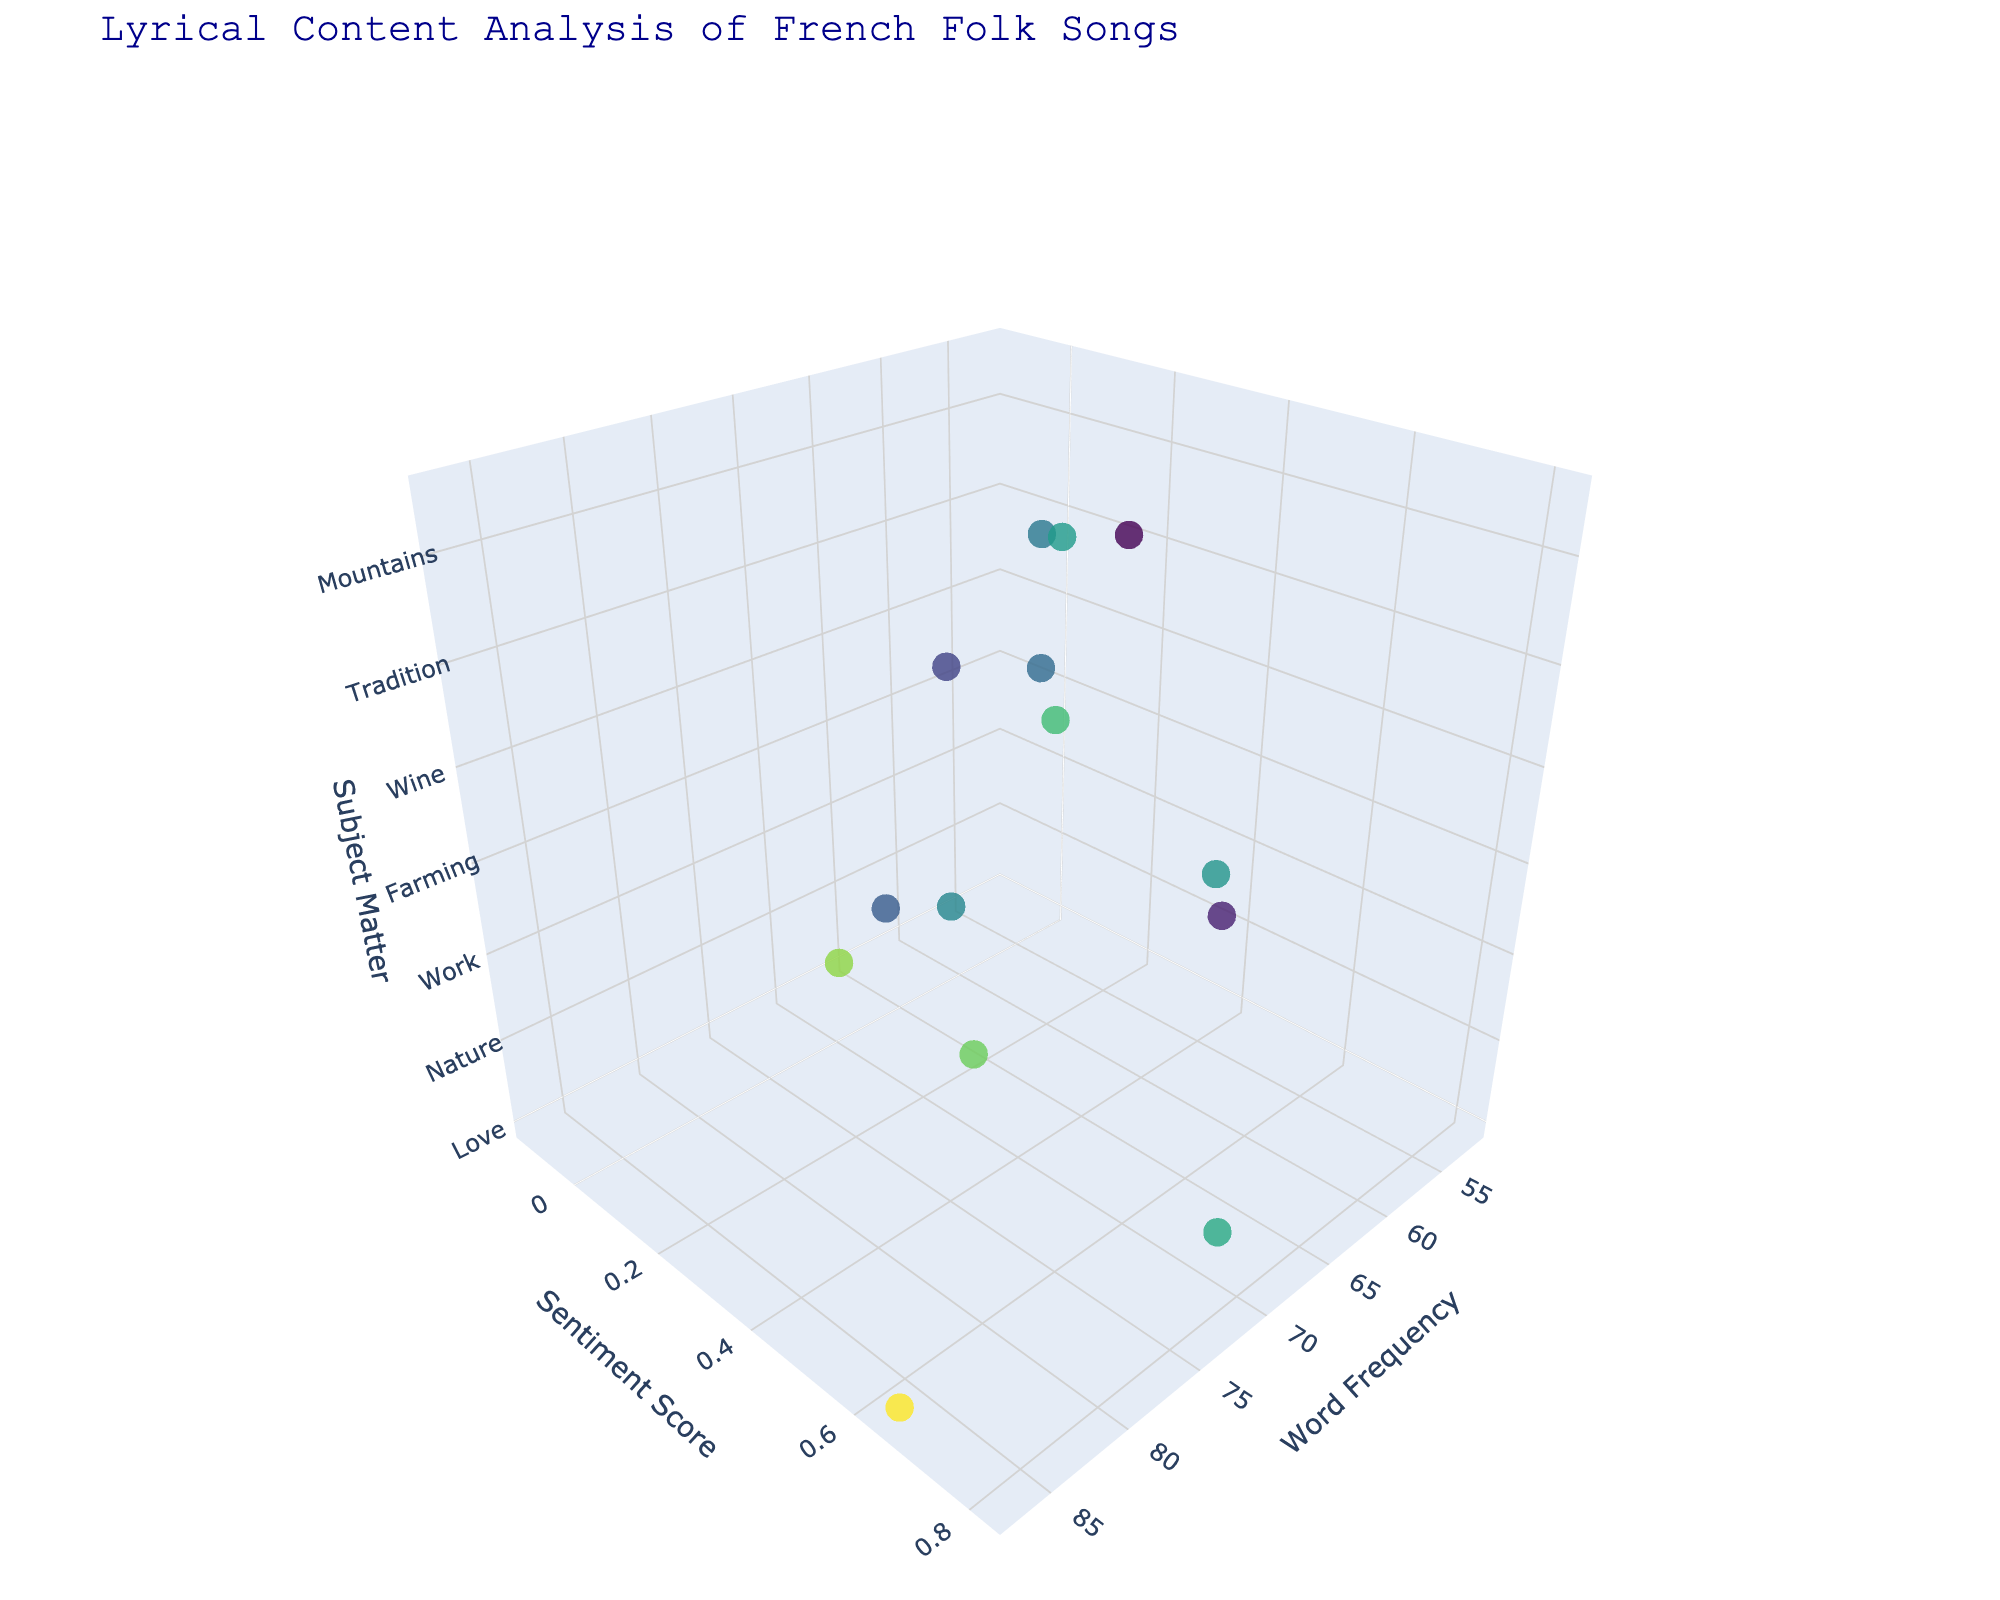What is the title of the plot? The title is usually displayed at the top of a plot, often in a larger and more prominent font. In this case, it reads 'Lyrical Content Analysis of French Folk Songs'.
Answer: Lyrical Content Analysis of French Folk Songs How many regions are represented in the plot? By counting the number of distinct data points, specifically looking for unique text labels associated with each marker, we find there are 14 regions.
Answer: 14 Which region has the highest word frequency? To answer this, we need to look for the data point that is farthest along the x-axis. According to the data, Brittany has the highest word frequency of 87.
Answer: Brittany Which region has the lowest sentiment score? We need to identify the point with the minimum y-coordinate value. From the data, Normandy has the lowest sentiment score at -0.12.
Answer: Normandy What subject matter is associated with the highest sentiment score? To find this, we look at the highest y-axis value and check the corresponding z-axis label. Provence has the highest sentiment score of 0.82 and its subject matter is Nature.
Answer: Nature Which region is closest to the center of the plot in terms of word frequency and sentiment score? We calculate the Euclidean distance from the center (average of all data points). First, find the mean word frequency and sentiment score, then the distance of each point to this mean. After comparing distances, we find Burgundy is closest to the center.
Answer: Burgundy How do Aquitaine and Auvergne differ in terms of lyrical content? Comparing the data points for Aquitaine and Auvergne shows that Aquitaine has higher word frequency (81 vs. 59) and a higher sentiment score (0.38 vs. -0.05). They also differ in subject matter: Aquitaine focuses on Farming while Auvergne deals with Hardship.
Answer: Aquitaine has higher word frequency and sentiment score, focuses on Farming instead of Hardship What is the average sentiment score across all regions? To find the average, sum all sentiment scores and divide by the number of regions: (0.65 + (-0.12) + 0.82 + 0.43 + 0.21 + 0.56 + 0.38 + (-0.05) + 0.72 + 0.28 + 0.15 + 0.61 + 0.33 + 0.49) / 14 = 5.46 / 14 = 0.39.
Answer: 0.39 Which regions have a higher than average word frequency? The average word frequency is (87 + 62 + 73 + 55 + 68 + 79 + 81 + 59 + 70 + 64 + 52 + 76 + 66 + 71) / 14 = 962 / 14 = 68.86. Regions with higher than this word frequency are Brittany, Provence, Loire Valley, Aquitaine, and Champagne.
Answer: Brittany, Provence, Loire Valley, Aquitaine, Champagne What is the relationship between sentiment score and subject matter? By examining the plot, we can group regions by subject matter and assess their sentiment scores to understand the trend. For instance, Love, Nature, Celebration, and Wine tend to have higher sentiment scores, while War and Hardship show lower scores. This indicates a correlation where positive subjects often yield higher sentiment scores, and negative subjects yield lower scores.
Answer: Positive subjects have higher sentiment scores, negative subjects have lower scores 